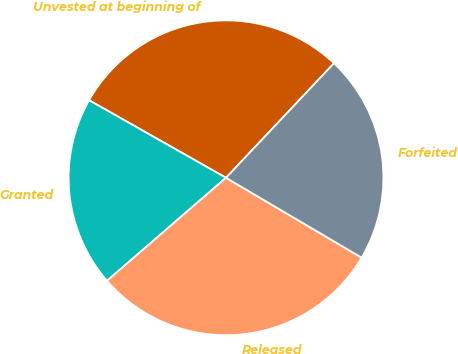<chart> <loc_0><loc_0><loc_500><loc_500><pie_chart><fcel>Unvested at beginning of<fcel>Granted<fcel>Released<fcel>Forfeited<nl><fcel>28.83%<fcel>19.56%<fcel>30.17%<fcel>21.44%<nl></chart> 